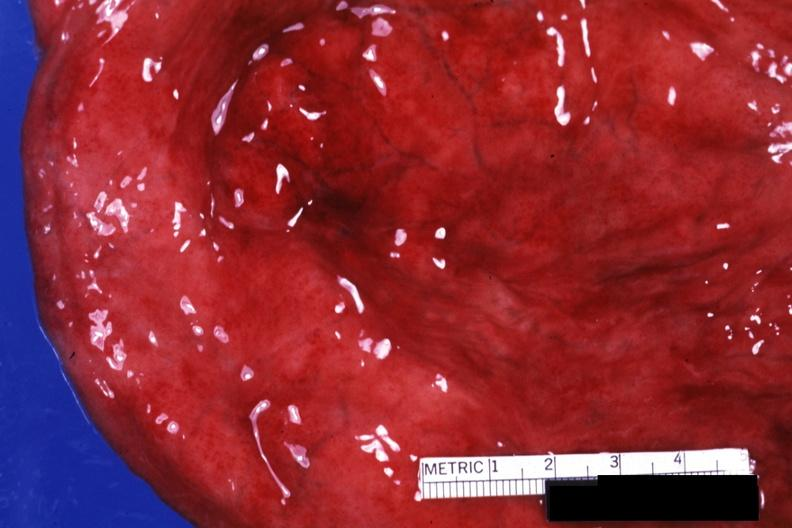s nodular parenchyma and dense present?
Answer the question using a single word or phrase. No 